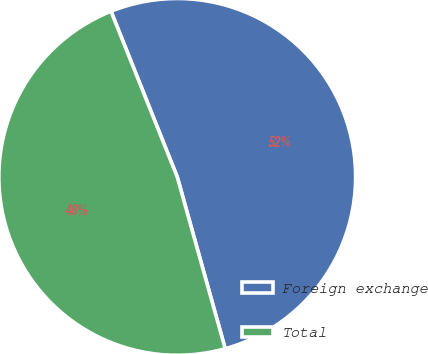Convert chart to OTSL. <chart><loc_0><loc_0><loc_500><loc_500><pie_chart><fcel>Foreign exchange<fcel>Total<nl><fcel>51.72%<fcel>48.28%<nl></chart> 